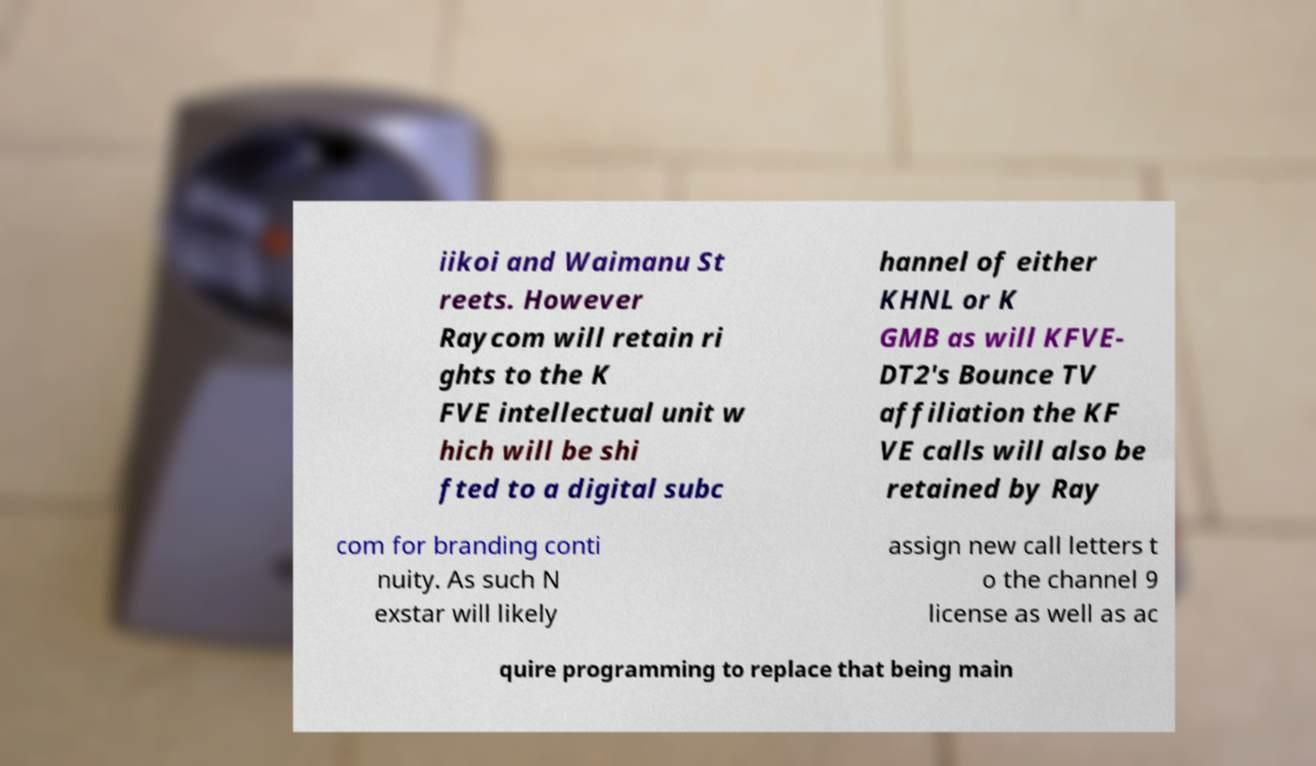Could you extract and type out the text from this image? iikoi and Waimanu St reets. However Raycom will retain ri ghts to the K FVE intellectual unit w hich will be shi fted to a digital subc hannel of either KHNL or K GMB as will KFVE- DT2's Bounce TV affiliation the KF VE calls will also be retained by Ray com for branding conti nuity. As such N exstar will likely assign new call letters t o the channel 9 license as well as ac quire programming to replace that being main 